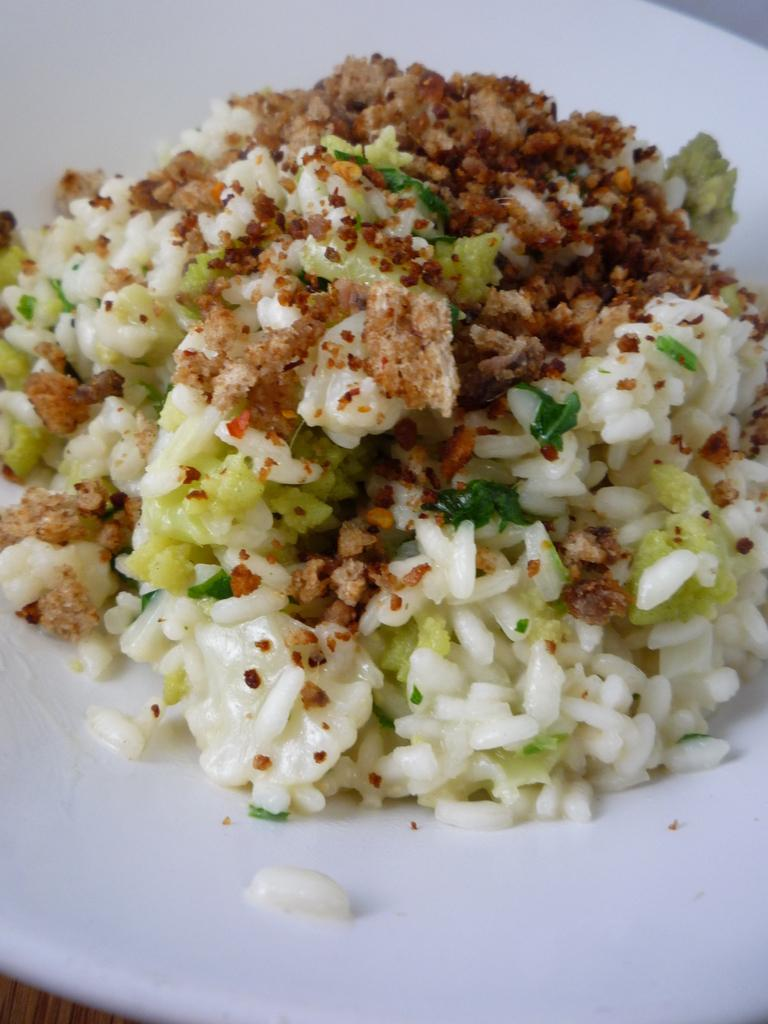What is the main object in the center of the image? There is a table in the center of the image. What is placed on the table? There is a white color plate on the table. What can be seen on the plate? There is a food item on the plate. What type of leather is used to make the food item on the plate? There is no leather present in the image, and the food item is not made of leather. 